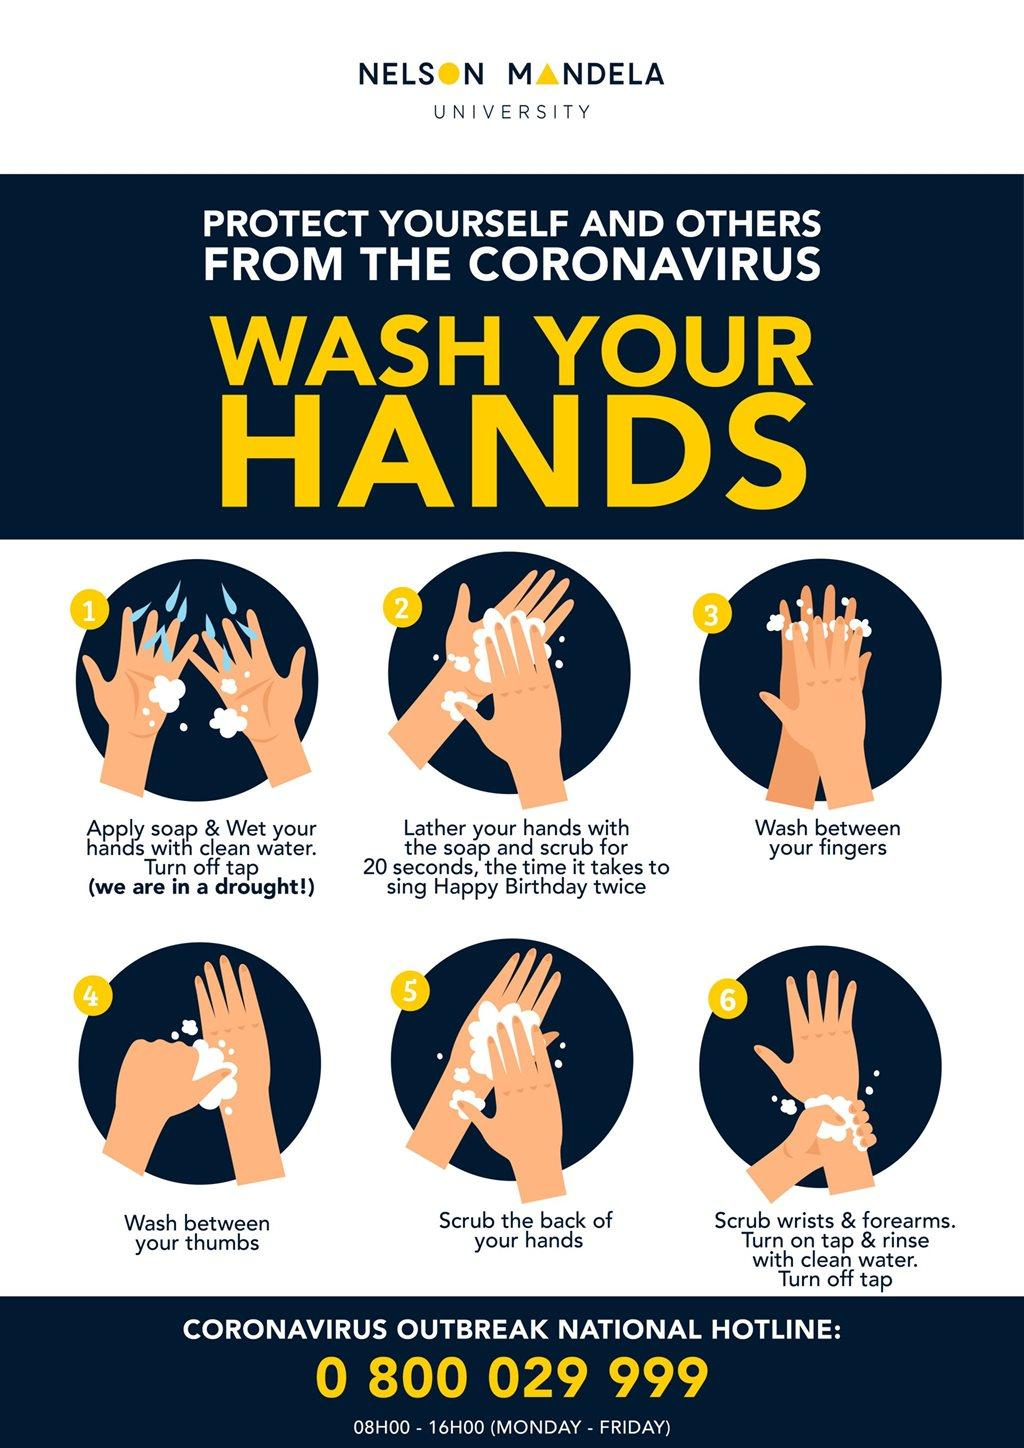List a handful of essential elements in this visual. It takes approximately 20 seconds to sing 'Happy Birthday' song twice. 